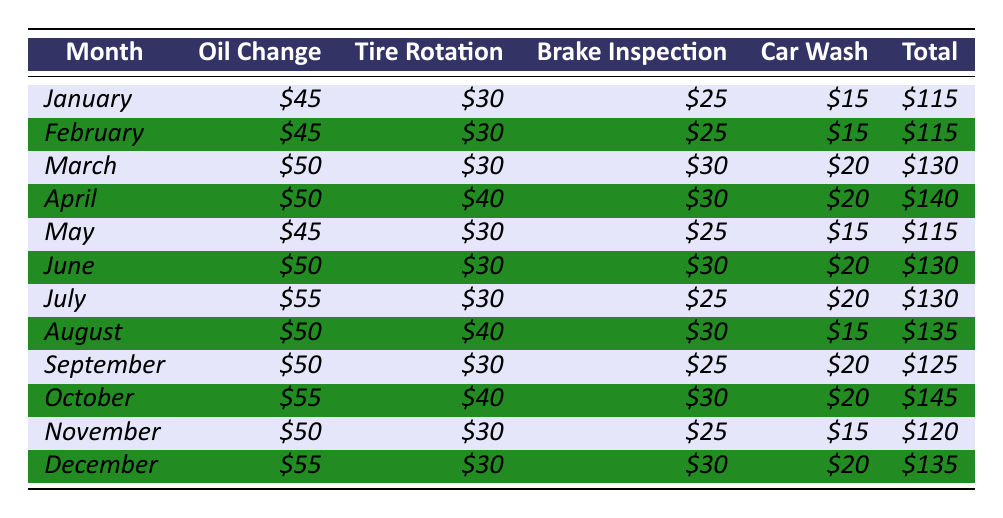What is the total expense for car maintenance in April? In the table, we find the total expense for April listed directly. The total is reported as $140.
Answer: $140 How much did the oil change cost in December? The table shows a specific entry for December, where the oil change cost is listed as $55.
Answer: $55 Which month had the highest total expense? By looking at the total expenses for each month, October shows the highest total expense at $145.
Answer: October What is the average monthly expense for the car maintenance throughout the year? First, we sum all the monthly totals: $115 + $115 + $130 + $140 + $115 + $130 + $130 + $135 + $125 + $145 + $120 + $135 = $1,577. Then, divide that by 12 months to find the average: $1,577 ÷ 12 ≈ $131.42.
Answer: $131.42 Was the tire rotation cost ever $40? Checking the table, the tire rotation cost is listed as $40 in both April and August. Therefore, the answer is yes.
Answer: Yes In which month did the brake inspection cost the same as it did in January? In January, the brake inspection cost is $25. Scanning the table, we find this same cost in February, May, September, and November.
Answer: February, May, September, November What was the total amount spent on car washes from January to June? We take the car wash costs from January to June: $15 + $15 + $20 + $20 + $15 + $20 = $105.
Answer: $105 Which month had a total expense of $120 and what were its costs? The table shows November as having a total expense of $120. The individual costs are: oil change $50, tire rotation $30, brake inspection $25, and car wash $15.
Answer: November: oil change $50, tire rotation $30, brake inspection $25, car wash $15 How much more was spent in October compared to January? The total for October is $145 and for January it is $115. The difference is $145 - $115 = $30.
Answer: $30 Is the total expense for July greater than or less than that of February? July's total expense is $130 while February's is $115. Since $130 > $115, the answer is that it is greater.
Answer: Greater 